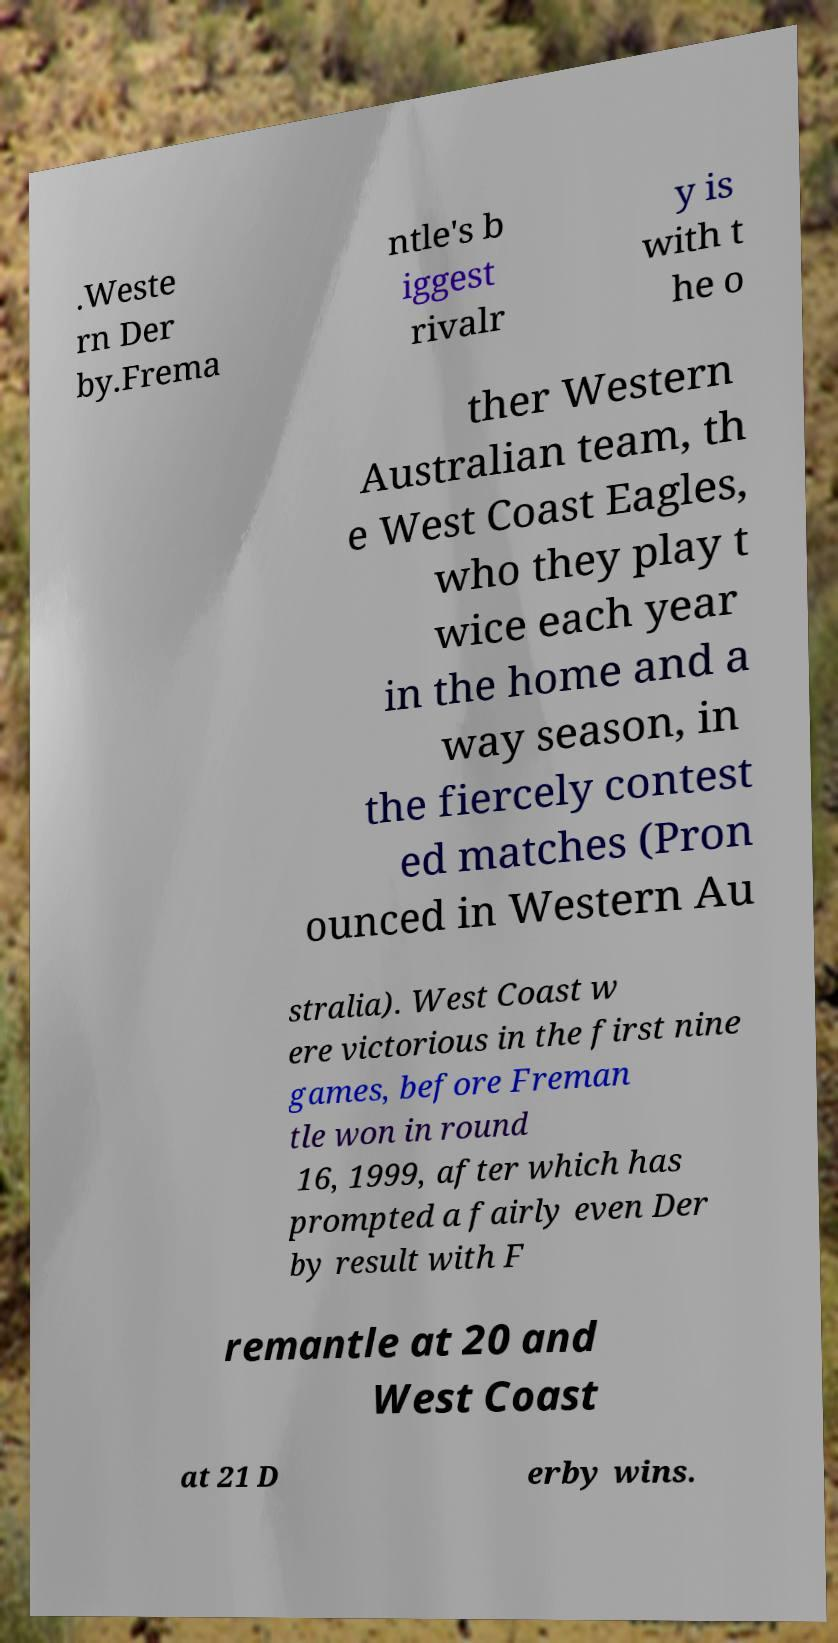Can you accurately transcribe the text from the provided image for me? .Weste rn Der by.Frema ntle's b iggest rivalr y is with t he o ther Western Australian team, th e West Coast Eagles, who they play t wice each year in the home and a way season, in the fiercely contest ed matches (Pron ounced in Western Au stralia). West Coast w ere victorious in the first nine games, before Freman tle won in round 16, 1999, after which has prompted a fairly even Der by result with F remantle at 20 and West Coast at 21 D erby wins. 